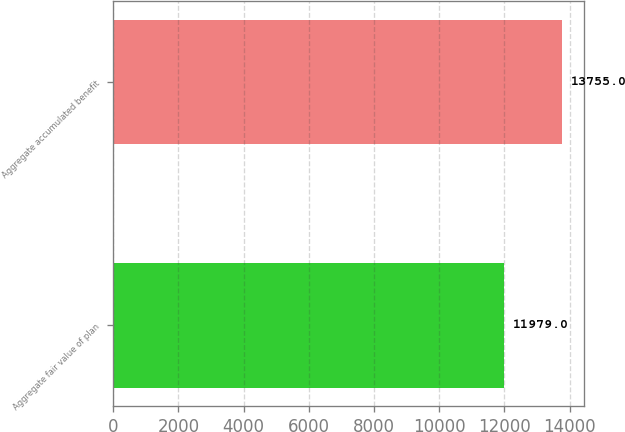Convert chart. <chart><loc_0><loc_0><loc_500><loc_500><bar_chart><fcel>Aggregate fair value of plan<fcel>Aggregate accumulated benefit<nl><fcel>11979<fcel>13755<nl></chart> 